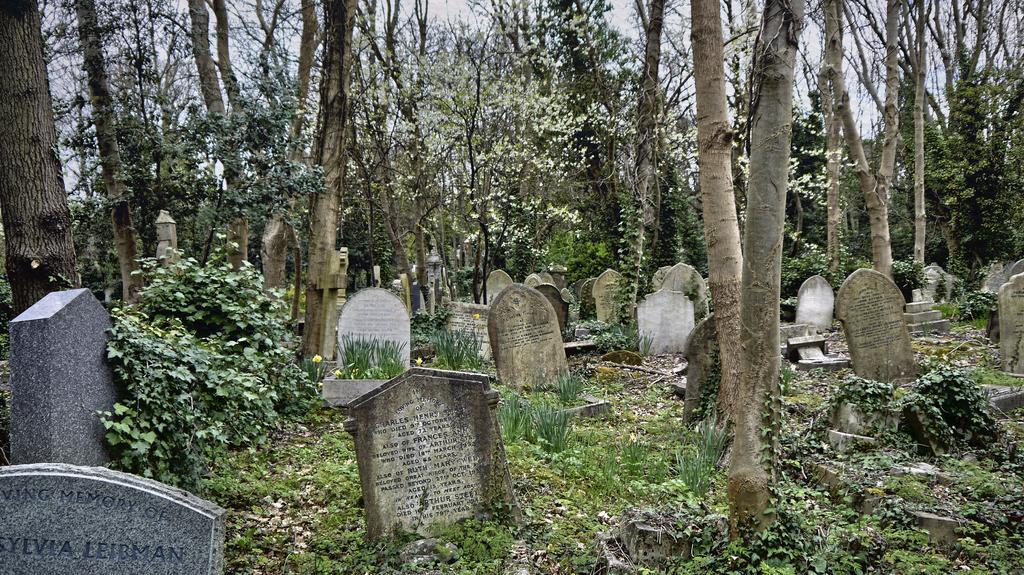What is the main subject of the image? There are many graves in the image. What can be seen in the background of the image? There are toys, plants, and grass in the background of the image. What is visible at the top of the image? The sky is visible at the top of the image. What type of bed is visible in the image? There is no bed present in the image. What action is being performed by the toys in the image? There are no toys performing any actions in the image; they are simply present in the background. 